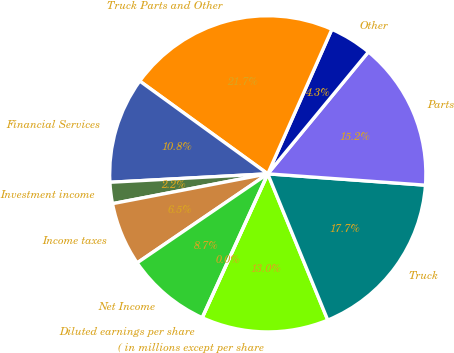<chart> <loc_0><loc_0><loc_500><loc_500><pie_chart><fcel>( in millions except per share<fcel>Truck<fcel>Parts<fcel>Other<fcel>Truck Parts and Other<fcel>Financial Services<fcel>Investment income<fcel>Income taxes<fcel>Net Income<fcel>Diluted earnings per share<nl><fcel>13.0%<fcel>17.66%<fcel>15.16%<fcel>4.34%<fcel>21.66%<fcel>10.83%<fcel>2.17%<fcel>6.5%<fcel>8.67%<fcel>0.0%<nl></chart> 